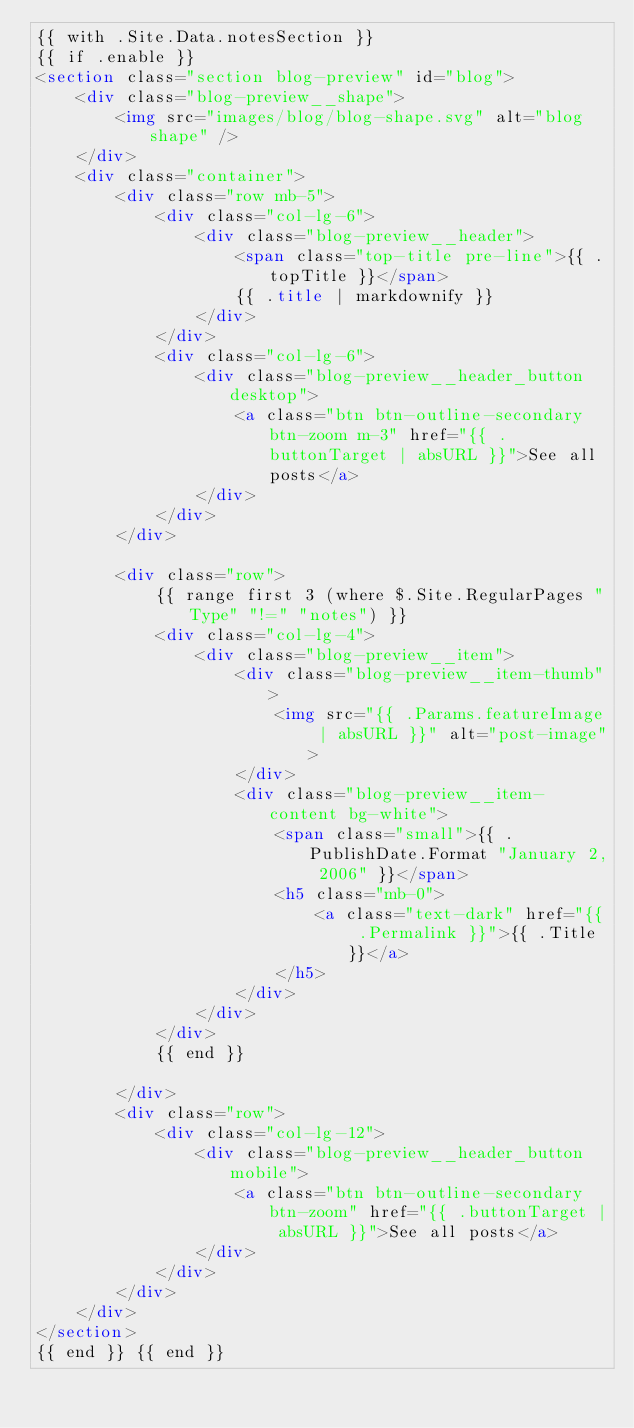Convert code to text. <code><loc_0><loc_0><loc_500><loc_500><_HTML_>{{ with .Site.Data.notesSection }}
{{ if .enable }}
<section class="section blog-preview" id="blog">
	<div class="blog-preview__shape">
		<img src="images/blog/blog-shape.svg" alt="blog shape" />
	</div>
	<div class="container">
		<div class="row mb-5">
			<div class="col-lg-6">
				<div class="blog-preview__header">
					<span class="top-title pre-line">{{ .topTitle }}</span>
					{{ .title | markdownify }}
				</div>
			</div>
			<div class="col-lg-6">
				<div class="blog-preview__header_button desktop">
					<a class="btn btn-outline-secondary  btn-zoom m-3" href="{{ .buttonTarget | absURL }}">See all posts</a>
				</div>
			</div>
		</div>

		<div class="row">
			{{ range first 3 (where $.Site.RegularPages "Type" "!=" "notes") }}
			<div class="col-lg-4">
				<div class="blog-preview__item">
					<div class="blog-preview__item-thumb">
						<img src="{{ .Params.featureImage | absURL }}" alt="post-image">
					</div>
					<div class="blog-preview__item-content bg-white">
						<span class="small">{{ .PublishDate.Format "January 2, 2006" }}</span>
						<h5 class="mb-0">
							<a class="text-dark" href="{{ .Permalink }}">{{ .Title }}</a>
						</h5>
					</div>
				</div>
			</div>
			{{ end }}

		</div>
		<div class="row">
			<div class="col-lg-12">
				<div class="blog-preview__header_button mobile">
					<a class="btn btn-outline-secondary btn-zoom" href="{{ .buttonTarget | absURL }}">See all posts</a>
				</div>
			</div>
		</div>
	</div>
</section>
{{ end }} {{ end }}</code> 